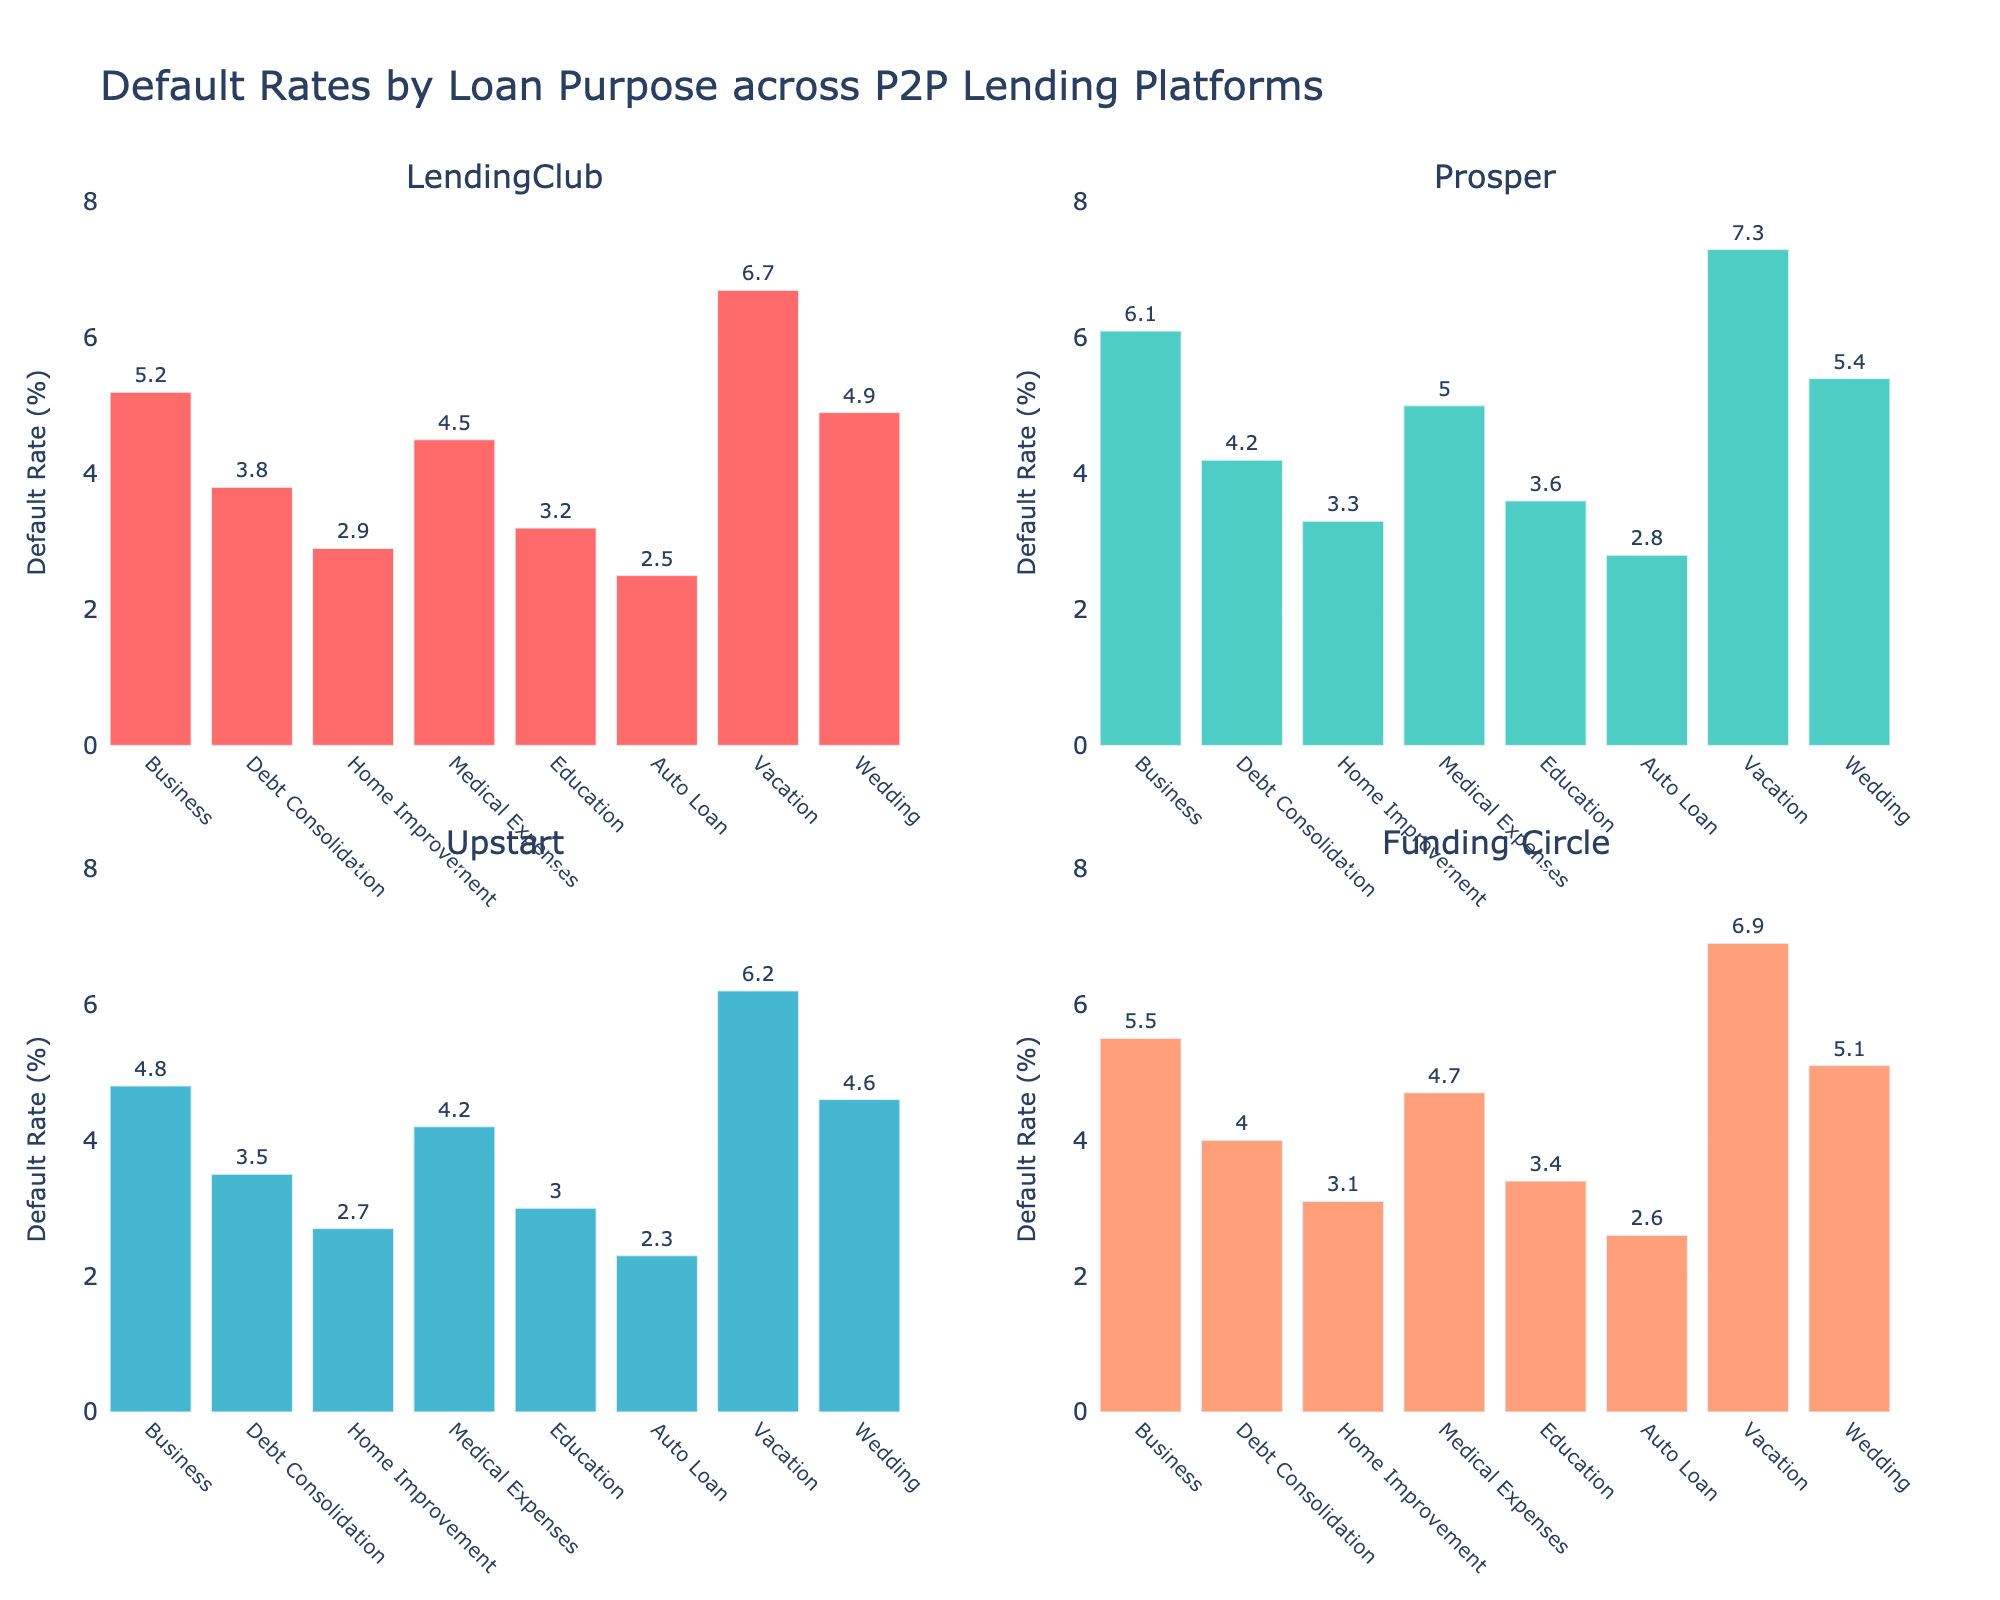What is the title of the figure? The title is displayed at the top center of the figure. It summarizes what the figure is about.
Answer: Default Rates by Loan Purpose across P2P Lending Platforms Which lending platform has the highest default rate for vacation loans? Look at the Vacation loan bars across all subplots and identify which one is the tallest.
Answer: Prosper What is the range of the y-axis for each subplot? Each y-axis has a title and scale shown on the left side of each subplot. The minimum value is typically 0, and the maximum value can be read directly.
Answer: 0 to 8 What is the default rate for medical expenses loans on LendingClub? Find the bar representing Medical Expenses in the LendingClub subplot and read the value from the top of the bar.
Answer: 4.5% Which loan purpose has the lowest default rate on Upstart? Examine each bar in the Upstart subplot and find the one that is the shortest.
Answer: Auto Loan Calculate the average default rate for debt consolidation loans across all platforms. First, locate the Debt Consolidation bars in all subplots. Sum their heights and then divide by the number of platforms (4): (3.8 + 4.2 + 3.5 + 4.0) / 4 = 3.88
Answer: 3.88% Compare the default rates for home improvement loans between LendingClub and Funding Circle. Which one is higher? Look at the Home Improvement bars in both the LendingClub and Funding Circle subplots. The taller bar corresponds to the higher default rate.
Answer: LendingClub Which platform has the most varied (highest spread) default rates across different loan purposes? Examine the range of the bars' heights in each subplot. The platform with the greatest difference between its highest and lowest bars has the most varied default rates.
Answer: Prosper Identify which loan purpose and platform combination has the second highest default rate among all shown. First, find the highest default rate, then look for the next highest bar among all subplots.
Answer: Vacation on LendingClub What is the difference in default rates between wedding loans and education loans on Prosper? Locate the Wedding and Education bars in the Prosper subplot. Subtract the value of Education from Wedding: 5.4 - 3.6
Answer: 1.8 